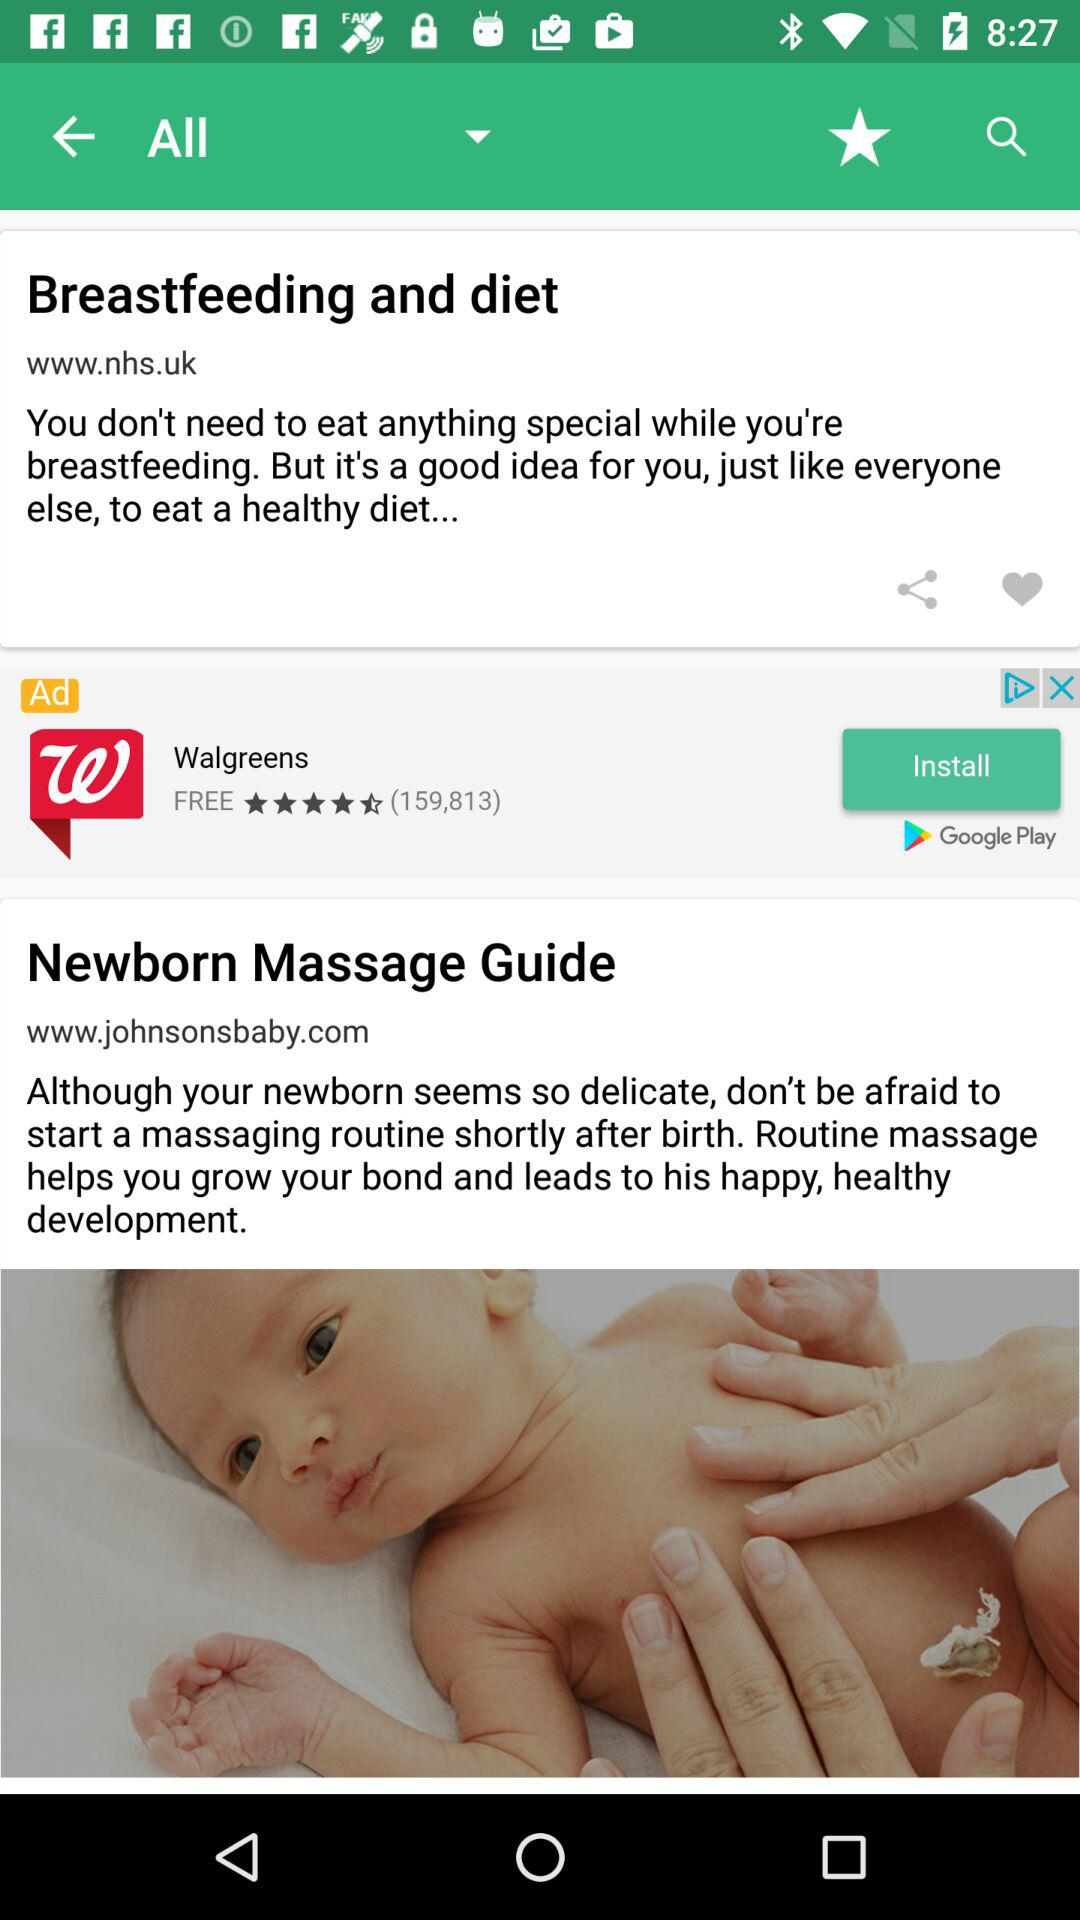How many articles are there?
Answer the question using a single word or phrase. 2 